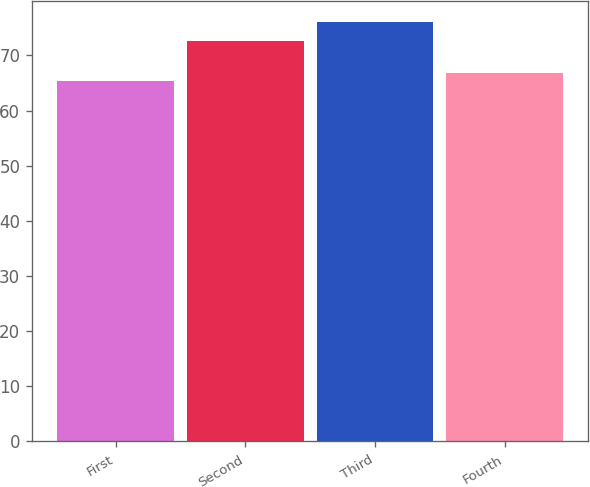Convert chart to OTSL. <chart><loc_0><loc_0><loc_500><loc_500><bar_chart><fcel>First<fcel>Second<fcel>Third<fcel>Fourth<nl><fcel>65.38<fcel>72.67<fcel>75.99<fcel>66.71<nl></chart> 